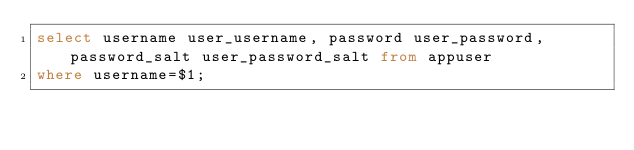Convert code to text. <code><loc_0><loc_0><loc_500><loc_500><_SQL_>select username user_username, password user_password, password_salt user_password_salt from appuser
where username=$1;
</code> 